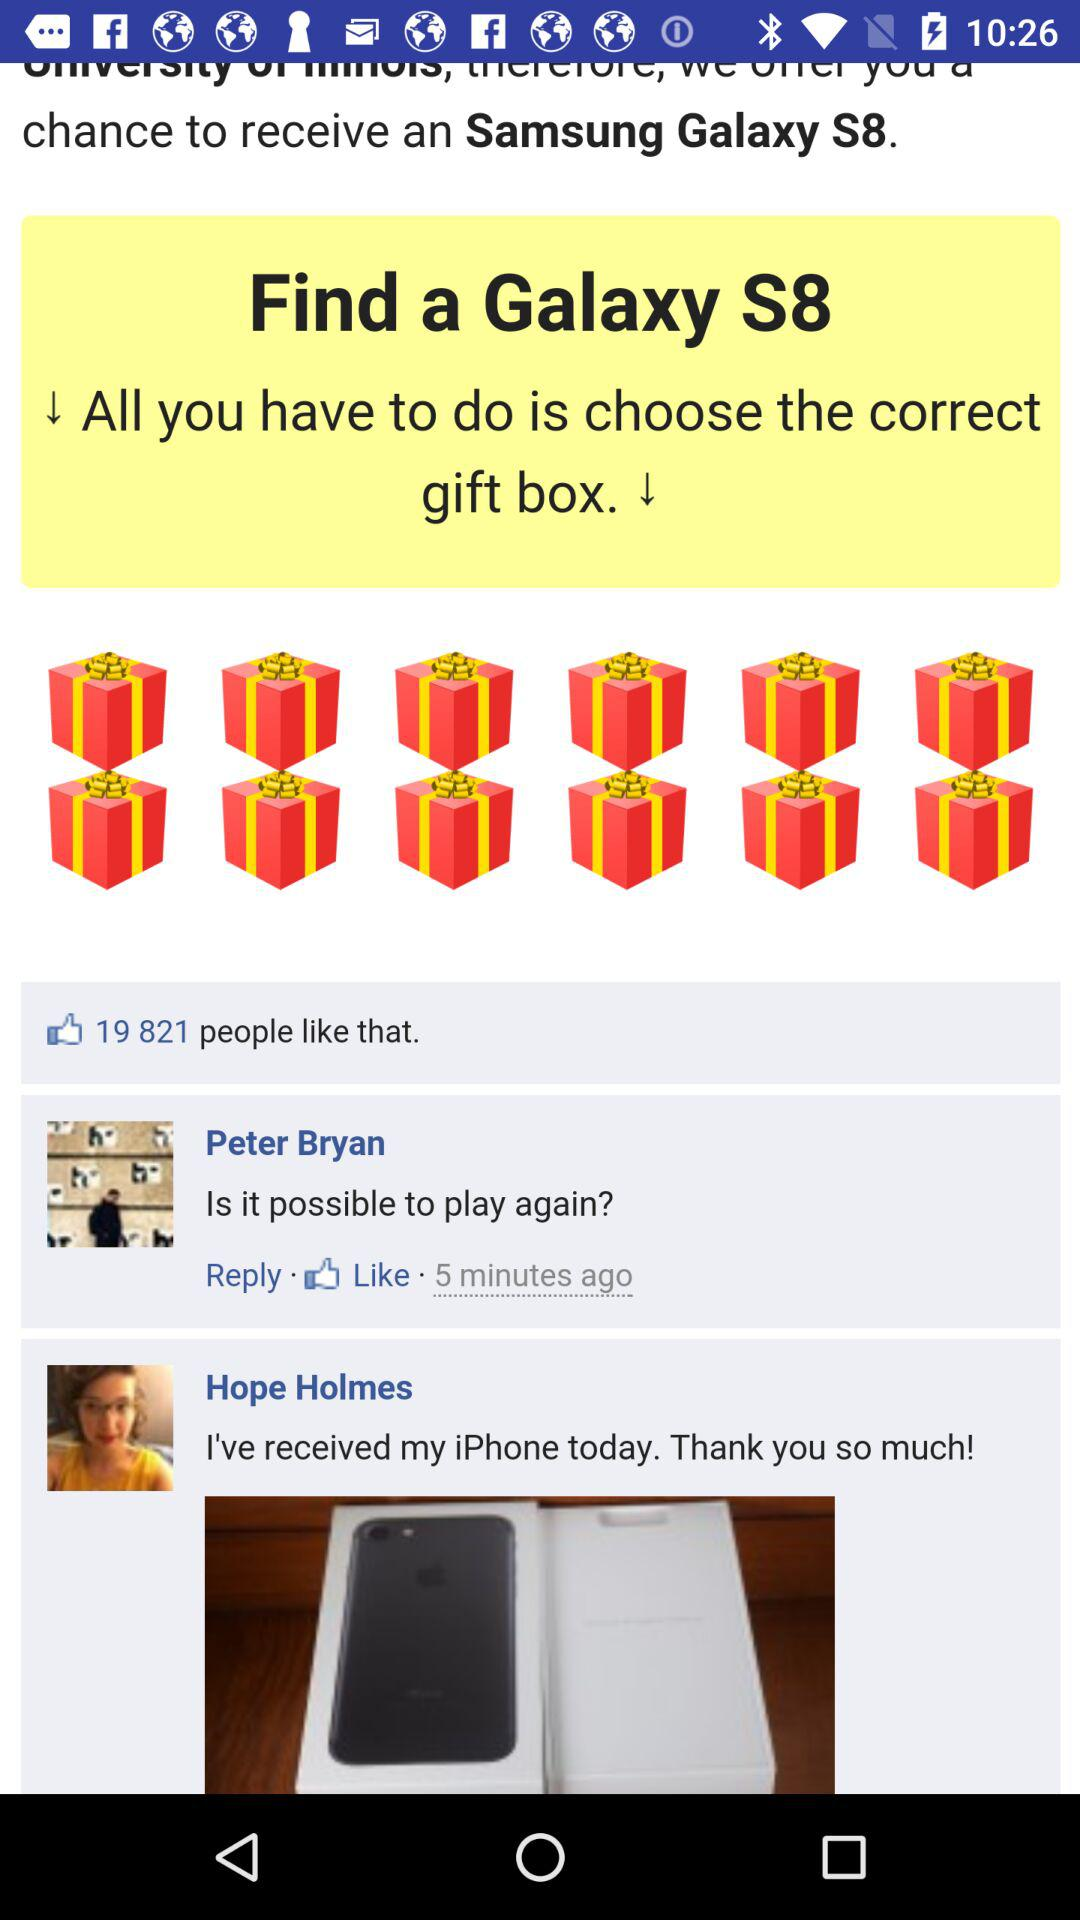How many people liked the post? The post was liked by 19,821 people. 